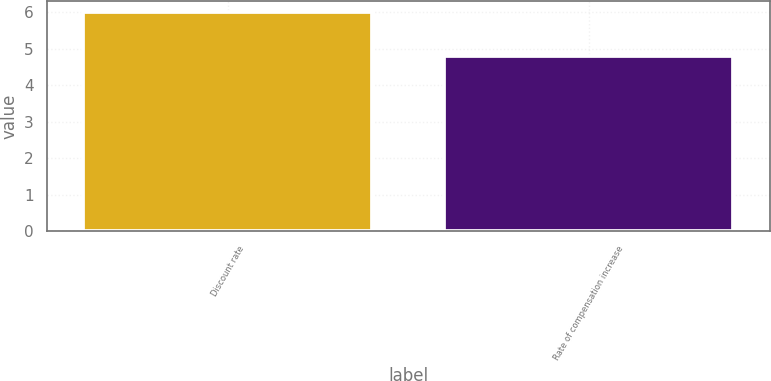<chart> <loc_0><loc_0><loc_500><loc_500><bar_chart><fcel>Discount rate<fcel>Rate of compensation increase<nl><fcel>6<fcel>4.8<nl></chart> 